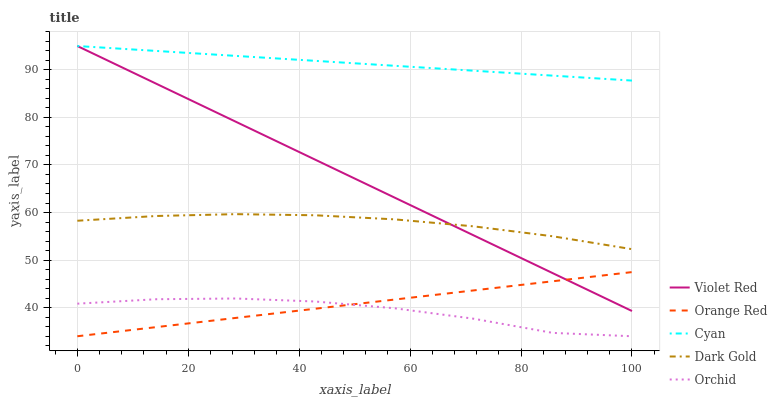Does Orchid have the minimum area under the curve?
Answer yes or no. Yes. Does Cyan have the maximum area under the curve?
Answer yes or no. Yes. Does Violet Red have the minimum area under the curve?
Answer yes or no. No. Does Violet Red have the maximum area under the curve?
Answer yes or no. No. Is Violet Red the smoothest?
Answer yes or no. Yes. Is Orchid the roughest?
Answer yes or no. Yes. Is Orchid the smoothest?
Answer yes or no. No. Is Violet Red the roughest?
Answer yes or no. No. Does Violet Red have the lowest value?
Answer yes or no. No. Does Violet Red have the highest value?
Answer yes or no. Yes. Does Orchid have the highest value?
Answer yes or no. No. Is Orchid less than Cyan?
Answer yes or no. Yes. Is Cyan greater than Orange Red?
Answer yes or no. Yes. Does Violet Red intersect Orange Red?
Answer yes or no. Yes. Is Violet Red less than Orange Red?
Answer yes or no. No. Is Violet Red greater than Orange Red?
Answer yes or no. No. Does Orchid intersect Cyan?
Answer yes or no. No. 